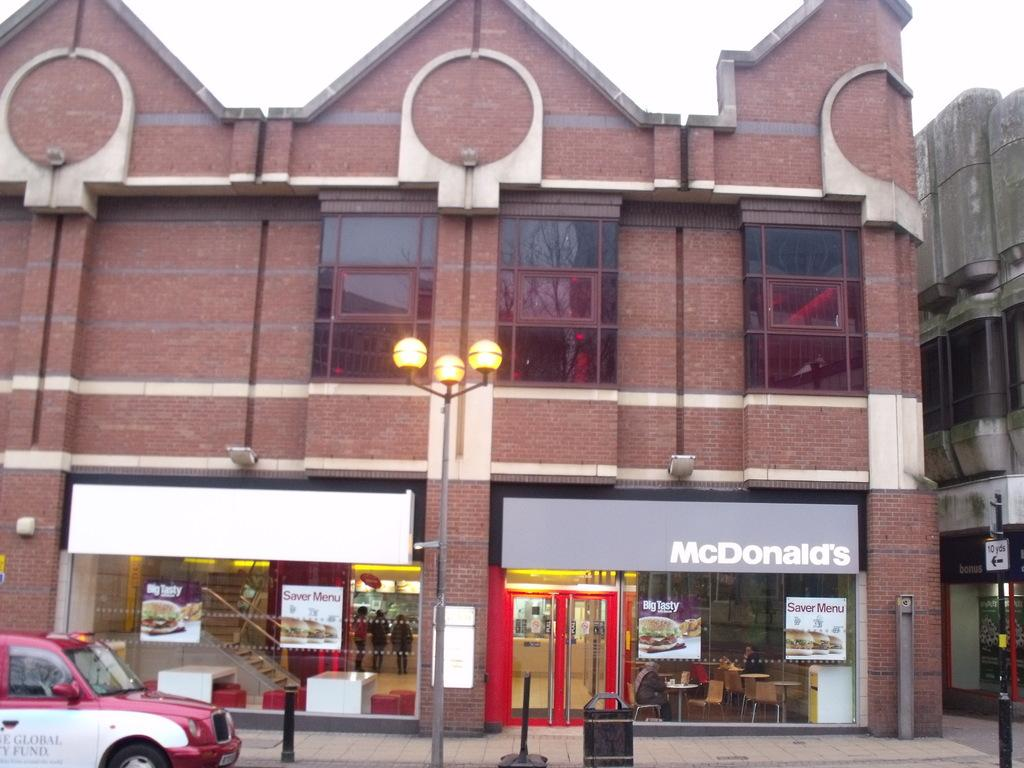<image>
Relay a brief, clear account of the picture shown. The restaurant on the far left is a Mc Donalds. 